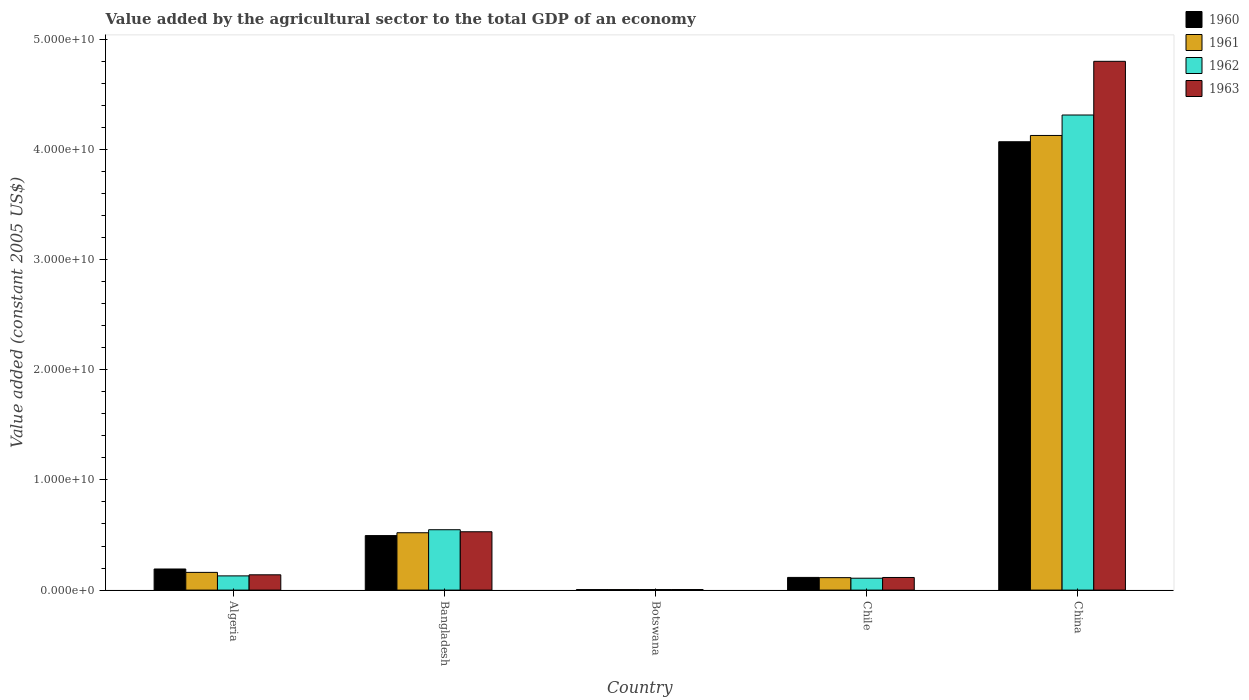How many groups of bars are there?
Your response must be concise. 5. Are the number of bars per tick equal to the number of legend labels?
Offer a very short reply. Yes. How many bars are there on the 5th tick from the left?
Ensure brevity in your answer.  4. How many bars are there on the 4th tick from the right?
Provide a succinct answer. 4. What is the label of the 2nd group of bars from the left?
Offer a terse response. Bangladesh. What is the value added by the agricultural sector in 1961 in Bangladesh?
Offer a terse response. 5.21e+09. Across all countries, what is the maximum value added by the agricultural sector in 1963?
Make the answer very short. 4.80e+1. Across all countries, what is the minimum value added by the agricultural sector in 1961?
Make the answer very short. 4.86e+07. In which country was the value added by the agricultural sector in 1961 minimum?
Your answer should be compact. Botswana. What is the total value added by the agricultural sector in 1961 in the graph?
Offer a terse response. 4.93e+1. What is the difference between the value added by the agricultural sector in 1961 in Bangladesh and that in Chile?
Give a very brief answer. 4.08e+09. What is the difference between the value added by the agricultural sector in 1961 in Algeria and the value added by the agricultural sector in 1962 in Chile?
Provide a succinct answer. 5.29e+08. What is the average value added by the agricultural sector in 1962 per country?
Offer a terse response. 1.02e+1. What is the difference between the value added by the agricultural sector of/in 1960 and value added by the agricultural sector of/in 1961 in Algeria?
Give a very brief answer. 3.07e+08. In how many countries, is the value added by the agricultural sector in 1960 greater than 20000000000 US$?
Ensure brevity in your answer.  1. What is the ratio of the value added by the agricultural sector in 1960 in Algeria to that in Botswana?
Provide a short and direct response. 40.37. What is the difference between the highest and the second highest value added by the agricultural sector in 1961?
Give a very brief answer. -3.61e+1. What is the difference between the highest and the lowest value added by the agricultural sector in 1962?
Your response must be concise. 4.31e+1. Is the sum of the value added by the agricultural sector in 1963 in Bangladesh and Botswana greater than the maximum value added by the agricultural sector in 1961 across all countries?
Ensure brevity in your answer.  No. Is it the case that in every country, the sum of the value added by the agricultural sector in 1963 and value added by the agricultural sector in 1960 is greater than the sum of value added by the agricultural sector in 1961 and value added by the agricultural sector in 1962?
Your answer should be very brief. No. What does the 2nd bar from the left in China represents?
Provide a succinct answer. 1961. What does the 2nd bar from the right in Bangladesh represents?
Provide a succinct answer. 1962. Is it the case that in every country, the sum of the value added by the agricultural sector in 1961 and value added by the agricultural sector in 1962 is greater than the value added by the agricultural sector in 1960?
Provide a short and direct response. Yes. Are all the bars in the graph horizontal?
Keep it short and to the point. No. How many countries are there in the graph?
Make the answer very short. 5. Does the graph contain any zero values?
Provide a short and direct response. No. How many legend labels are there?
Provide a succinct answer. 4. How are the legend labels stacked?
Provide a succinct answer. Vertical. What is the title of the graph?
Make the answer very short. Value added by the agricultural sector to the total GDP of an economy. What is the label or title of the Y-axis?
Keep it short and to the point. Value added (constant 2005 US$). What is the Value added (constant 2005 US$) of 1960 in Algeria?
Give a very brief answer. 1.92e+09. What is the Value added (constant 2005 US$) of 1961 in Algeria?
Make the answer very short. 1.61e+09. What is the Value added (constant 2005 US$) of 1962 in Algeria?
Give a very brief answer. 1.29e+09. What is the Value added (constant 2005 US$) in 1963 in Algeria?
Provide a succinct answer. 1.39e+09. What is the Value added (constant 2005 US$) in 1960 in Bangladesh?
Offer a terse response. 4.95e+09. What is the Value added (constant 2005 US$) in 1961 in Bangladesh?
Offer a terse response. 5.21e+09. What is the Value added (constant 2005 US$) of 1962 in Bangladesh?
Give a very brief answer. 5.48e+09. What is the Value added (constant 2005 US$) of 1963 in Bangladesh?
Make the answer very short. 5.30e+09. What is the Value added (constant 2005 US$) of 1960 in Botswana?
Give a very brief answer. 4.74e+07. What is the Value added (constant 2005 US$) of 1961 in Botswana?
Give a very brief answer. 4.86e+07. What is the Value added (constant 2005 US$) in 1962 in Botswana?
Your answer should be compact. 5.04e+07. What is the Value added (constant 2005 US$) of 1963 in Botswana?
Offer a very short reply. 5.21e+07. What is the Value added (constant 2005 US$) in 1960 in Chile?
Give a very brief answer. 1.15e+09. What is the Value added (constant 2005 US$) of 1961 in Chile?
Ensure brevity in your answer.  1.13e+09. What is the Value added (constant 2005 US$) of 1962 in Chile?
Offer a terse response. 1.08e+09. What is the Value added (constant 2005 US$) in 1963 in Chile?
Your response must be concise. 1.15e+09. What is the Value added (constant 2005 US$) of 1960 in China?
Make the answer very short. 4.07e+1. What is the Value added (constant 2005 US$) of 1961 in China?
Your answer should be compact. 4.13e+1. What is the Value added (constant 2005 US$) in 1962 in China?
Keep it short and to the point. 4.31e+1. What is the Value added (constant 2005 US$) of 1963 in China?
Keep it short and to the point. 4.80e+1. Across all countries, what is the maximum Value added (constant 2005 US$) of 1960?
Make the answer very short. 4.07e+1. Across all countries, what is the maximum Value added (constant 2005 US$) in 1961?
Keep it short and to the point. 4.13e+1. Across all countries, what is the maximum Value added (constant 2005 US$) of 1962?
Provide a short and direct response. 4.31e+1. Across all countries, what is the maximum Value added (constant 2005 US$) of 1963?
Your answer should be very brief. 4.80e+1. Across all countries, what is the minimum Value added (constant 2005 US$) in 1960?
Keep it short and to the point. 4.74e+07. Across all countries, what is the minimum Value added (constant 2005 US$) in 1961?
Keep it short and to the point. 4.86e+07. Across all countries, what is the minimum Value added (constant 2005 US$) in 1962?
Make the answer very short. 5.04e+07. Across all countries, what is the minimum Value added (constant 2005 US$) in 1963?
Keep it short and to the point. 5.21e+07. What is the total Value added (constant 2005 US$) of 1960 in the graph?
Offer a very short reply. 4.88e+1. What is the total Value added (constant 2005 US$) of 1961 in the graph?
Provide a short and direct response. 4.93e+1. What is the total Value added (constant 2005 US$) of 1962 in the graph?
Make the answer very short. 5.10e+1. What is the total Value added (constant 2005 US$) of 1963 in the graph?
Keep it short and to the point. 5.59e+1. What is the difference between the Value added (constant 2005 US$) of 1960 in Algeria and that in Bangladesh?
Offer a terse response. -3.03e+09. What is the difference between the Value added (constant 2005 US$) in 1961 in Algeria and that in Bangladesh?
Your answer should be compact. -3.60e+09. What is the difference between the Value added (constant 2005 US$) in 1962 in Algeria and that in Bangladesh?
Keep it short and to the point. -4.19e+09. What is the difference between the Value added (constant 2005 US$) of 1963 in Algeria and that in Bangladesh?
Your response must be concise. -3.91e+09. What is the difference between the Value added (constant 2005 US$) of 1960 in Algeria and that in Botswana?
Provide a short and direct response. 1.87e+09. What is the difference between the Value added (constant 2005 US$) in 1961 in Algeria and that in Botswana?
Ensure brevity in your answer.  1.56e+09. What is the difference between the Value added (constant 2005 US$) of 1962 in Algeria and that in Botswana?
Your answer should be very brief. 1.24e+09. What is the difference between the Value added (constant 2005 US$) in 1963 in Algeria and that in Botswana?
Offer a very short reply. 1.34e+09. What is the difference between the Value added (constant 2005 US$) of 1960 in Algeria and that in Chile?
Keep it short and to the point. 7.63e+08. What is the difference between the Value added (constant 2005 US$) of 1961 in Algeria and that in Chile?
Provide a short and direct response. 4.78e+08. What is the difference between the Value added (constant 2005 US$) in 1962 in Algeria and that in Chile?
Ensure brevity in your answer.  2.11e+08. What is the difference between the Value added (constant 2005 US$) of 1963 in Algeria and that in Chile?
Provide a short and direct response. 2.42e+08. What is the difference between the Value added (constant 2005 US$) in 1960 in Algeria and that in China?
Provide a short and direct response. -3.88e+1. What is the difference between the Value added (constant 2005 US$) of 1961 in Algeria and that in China?
Your response must be concise. -3.97e+1. What is the difference between the Value added (constant 2005 US$) of 1962 in Algeria and that in China?
Your answer should be very brief. -4.18e+1. What is the difference between the Value added (constant 2005 US$) of 1963 in Algeria and that in China?
Your response must be concise. -4.66e+1. What is the difference between the Value added (constant 2005 US$) in 1960 in Bangladesh and that in Botswana?
Provide a succinct answer. 4.90e+09. What is the difference between the Value added (constant 2005 US$) of 1961 in Bangladesh and that in Botswana?
Ensure brevity in your answer.  5.16e+09. What is the difference between the Value added (constant 2005 US$) in 1962 in Bangladesh and that in Botswana?
Provide a succinct answer. 5.43e+09. What is the difference between the Value added (constant 2005 US$) of 1963 in Bangladesh and that in Botswana?
Ensure brevity in your answer.  5.24e+09. What is the difference between the Value added (constant 2005 US$) in 1960 in Bangladesh and that in Chile?
Provide a short and direct response. 3.80e+09. What is the difference between the Value added (constant 2005 US$) of 1961 in Bangladesh and that in Chile?
Give a very brief answer. 4.08e+09. What is the difference between the Value added (constant 2005 US$) in 1962 in Bangladesh and that in Chile?
Offer a very short reply. 4.40e+09. What is the difference between the Value added (constant 2005 US$) of 1963 in Bangladesh and that in Chile?
Your answer should be compact. 4.15e+09. What is the difference between the Value added (constant 2005 US$) of 1960 in Bangladesh and that in China?
Provide a succinct answer. -3.57e+1. What is the difference between the Value added (constant 2005 US$) in 1961 in Bangladesh and that in China?
Ensure brevity in your answer.  -3.61e+1. What is the difference between the Value added (constant 2005 US$) in 1962 in Bangladesh and that in China?
Make the answer very short. -3.76e+1. What is the difference between the Value added (constant 2005 US$) in 1963 in Bangladesh and that in China?
Provide a succinct answer. -4.27e+1. What is the difference between the Value added (constant 2005 US$) of 1960 in Botswana and that in Chile?
Offer a terse response. -1.10e+09. What is the difference between the Value added (constant 2005 US$) in 1961 in Botswana and that in Chile?
Make the answer very short. -1.08e+09. What is the difference between the Value added (constant 2005 US$) of 1962 in Botswana and that in Chile?
Your answer should be compact. -1.03e+09. What is the difference between the Value added (constant 2005 US$) of 1963 in Botswana and that in Chile?
Your response must be concise. -1.09e+09. What is the difference between the Value added (constant 2005 US$) of 1960 in Botswana and that in China?
Your answer should be compact. -4.07e+1. What is the difference between the Value added (constant 2005 US$) of 1961 in Botswana and that in China?
Your answer should be very brief. -4.12e+1. What is the difference between the Value added (constant 2005 US$) of 1962 in Botswana and that in China?
Provide a short and direct response. -4.31e+1. What is the difference between the Value added (constant 2005 US$) of 1963 in Botswana and that in China?
Keep it short and to the point. -4.79e+1. What is the difference between the Value added (constant 2005 US$) in 1960 in Chile and that in China?
Offer a terse response. -3.95e+1. What is the difference between the Value added (constant 2005 US$) of 1961 in Chile and that in China?
Your answer should be very brief. -4.01e+1. What is the difference between the Value added (constant 2005 US$) in 1962 in Chile and that in China?
Offer a very short reply. -4.20e+1. What is the difference between the Value added (constant 2005 US$) in 1963 in Chile and that in China?
Ensure brevity in your answer.  -4.69e+1. What is the difference between the Value added (constant 2005 US$) of 1960 in Algeria and the Value added (constant 2005 US$) of 1961 in Bangladesh?
Your answer should be compact. -3.29e+09. What is the difference between the Value added (constant 2005 US$) in 1960 in Algeria and the Value added (constant 2005 US$) in 1962 in Bangladesh?
Ensure brevity in your answer.  -3.56e+09. What is the difference between the Value added (constant 2005 US$) of 1960 in Algeria and the Value added (constant 2005 US$) of 1963 in Bangladesh?
Your answer should be very brief. -3.38e+09. What is the difference between the Value added (constant 2005 US$) of 1961 in Algeria and the Value added (constant 2005 US$) of 1962 in Bangladesh?
Provide a short and direct response. -3.87e+09. What is the difference between the Value added (constant 2005 US$) in 1961 in Algeria and the Value added (constant 2005 US$) in 1963 in Bangladesh?
Your answer should be very brief. -3.69e+09. What is the difference between the Value added (constant 2005 US$) of 1962 in Algeria and the Value added (constant 2005 US$) of 1963 in Bangladesh?
Provide a short and direct response. -4.00e+09. What is the difference between the Value added (constant 2005 US$) in 1960 in Algeria and the Value added (constant 2005 US$) in 1961 in Botswana?
Your answer should be compact. 1.87e+09. What is the difference between the Value added (constant 2005 US$) of 1960 in Algeria and the Value added (constant 2005 US$) of 1962 in Botswana?
Your answer should be compact. 1.86e+09. What is the difference between the Value added (constant 2005 US$) in 1960 in Algeria and the Value added (constant 2005 US$) in 1963 in Botswana?
Your response must be concise. 1.86e+09. What is the difference between the Value added (constant 2005 US$) of 1961 in Algeria and the Value added (constant 2005 US$) of 1962 in Botswana?
Provide a succinct answer. 1.56e+09. What is the difference between the Value added (constant 2005 US$) of 1961 in Algeria and the Value added (constant 2005 US$) of 1963 in Botswana?
Provide a short and direct response. 1.56e+09. What is the difference between the Value added (constant 2005 US$) in 1962 in Algeria and the Value added (constant 2005 US$) in 1963 in Botswana?
Provide a succinct answer. 1.24e+09. What is the difference between the Value added (constant 2005 US$) of 1960 in Algeria and the Value added (constant 2005 US$) of 1961 in Chile?
Keep it short and to the point. 7.85e+08. What is the difference between the Value added (constant 2005 US$) in 1960 in Algeria and the Value added (constant 2005 US$) in 1962 in Chile?
Keep it short and to the point. 8.36e+08. What is the difference between the Value added (constant 2005 US$) in 1960 in Algeria and the Value added (constant 2005 US$) in 1963 in Chile?
Ensure brevity in your answer.  7.69e+08. What is the difference between the Value added (constant 2005 US$) in 1961 in Algeria and the Value added (constant 2005 US$) in 1962 in Chile?
Provide a short and direct response. 5.29e+08. What is the difference between the Value added (constant 2005 US$) in 1961 in Algeria and the Value added (constant 2005 US$) in 1963 in Chile?
Provide a short and direct response. 4.62e+08. What is the difference between the Value added (constant 2005 US$) in 1962 in Algeria and the Value added (constant 2005 US$) in 1963 in Chile?
Ensure brevity in your answer.  1.44e+08. What is the difference between the Value added (constant 2005 US$) in 1960 in Algeria and the Value added (constant 2005 US$) in 1961 in China?
Ensure brevity in your answer.  -3.94e+1. What is the difference between the Value added (constant 2005 US$) of 1960 in Algeria and the Value added (constant 2005 US$) of 1962 in China?
Provide a succinct answer. -4.12e+1. What is the difference between the Value added (constant 2005 US$) in 1960 in Algeria and the Value added (constant 2005 US$) in 1963 in China?
Provide a succinct answer. -4.61e+1. What is the difference between the Value added (constant 2005 US$) in 1961 in Algeria and the Value added (constant 2005 US$) in 1962 in China?
Give a very brief answer. -4.15e+1. What is the difference between the Value added (constant 2005 US$) of 1961 in Algeria and the Value added (constant 2005 US$) of 1963 in China?
Provide a short and direct response. -4.64e+1. What is the difference between the Value added (constant 2005 US$) of 1962 in Algeria and the Value added (constant 2005 US$) of 1963 in China?
Your response must be concise. -4.67e+1. What is the difference between the Value added (constant 2005 US$) in 1960 in Bangladesh and the Value added (constant 2005 US$) in 1961 in Botswana?
Provide a succinct answer. 4.90e+09. What is the difference between the Value added (constant 2005 US$) of 1960 in Bangladesh and the Value added (constant 2005 US$) of 1962 in Botswana?
Your answer should be compact. 4.90e+09. What is the difference between the Value added (constant 2005 US$) of 1960 in Bangladesh and the Value added (constant 2005 US$) of 1963 in Botswana?
Ensure brevity in your answer.  4.90e+09. What is the difference between the Value added (constant 2005 US$) in 1961 in Bangladesh and the Value added (constant 2005 US$) in 1962 in Botswana?
Ensure brevity in your answer.  5.16e+09. What is the difference between the Value added (constant 2005 US$) of 1961 in Bangladesh and the Value added (constant 2005 US$) of 1963 in Botswana?
Keep it short and to the point. 5.15e+09. What is the difference between the Value added (constant 2005 US$) of 1962 in Bangladesh and the Value added (constant 2005 US$) of 1963 in Botswana?
Ensure brevity in your answer.  5.43e+09. What is the difference between the Value added (constant 2005 US$) of 1960 in Bangladesh and the Value added (constant 2005 US$) of 1961 in Chile?
Provide a short and direct response. 3.82e+09. What is the difference between the Value added (constant 2005 US$) of 1960 in Bangladesh and the Value added (constant 2005 US$) of 1962 in Chile?
Provide a short and direct response. 3.87e+09. What is the difference between the Value added (constant 2005 US$) of 1960 in Bangladesh and the Value added (constant 2005 US$) of 1963 in Chile?
Provide a short and direct response. 3.80e+09. What is the difference between the Value added (constant 2005 US$) of 1961 in Bangladesh and the Value added (constant 2005 US$) of 1962 in Chile?
Make the answer very short. 4.13e+09. What is the difference between the Value added (constant 2005 US$) of 1961 in Bangladesh and the Value added (constant 2005 US$) of 1963 in Chile?
Give a very brief answer. 4.06e+09. What is the difference between the Value added (constant 2005 US$) of 1962 in Bangladesh and the Value added (constant 2005 US$) of 1963 in Chile?
Your response must be concise. 4.33e+09. What is the difference between the Value added (constant 2005 US$) in 1960 in Bangladesh and the Value added (constant 2005 US$) in 1961 in China?
Provide a succinct answer. -3.63e+1. What is the difference between the Value added (constant 2005 US$) of 1960 in Bangladesh and the Value added (constant 2005 US$) of 1962 in China?
Provide a succinct answer. -3.82e+1. What is the difference between the Value added (constant 2005 US$) in 1960 in Bangladesh and the Value added (constant 2005 US$) in 1963 in China?
Give a very brief answer. -4.30e+1. What is the difference between the Value added (constant 2005 US$) in 1961 in Bangladesh and the Value added (constant 2005 US$) in 1962 in China?
Offer a terse response. -3.79e+1. What is the difference between the Value added (constant 2005 US$) in 1961 in Bangladesh and the Value added (constant 2005 US$) in 1963 in China?
Your response must be concise. -4.28e+1. What is the difference between the Value added (constant 2005 US$) of 1962 in Bangladesh and the Value added (constant 2005 US$) of 1963 in China?
Give a very brief answer. -4.25e+1. What is the difference between the Value added (constant 2005 US$) in 1960 in Botswana and the Value added (constant 2005 US$) in 1961 in Chile?
Provide a succinct answer. -1.08e+09. What is the difference between the Value added (constant 2005 US$) in 1960 in Botswana and the Value added (constant 2005 US$) in 1962 in Chile?
Your answer should be compact. -1.03e+09. What is the difference between the Value added (constant 2005 US$) of 1960 in Botswana and the Value added (constant 2005 US$) of 1963 in Chile?
Ensure brevity in your answer.  -1.10e+09. What is the difference between the Value added (constant 2005 US$) of 1961 in Botswana and the Value added (constant 2005 US$) of 1962 in Chile?
Make the answer very short. -1.03e+09. What is the difference between the Value added (constant 2005 US$) in 1961 in Botswana and the Value added (constant 2005 US$) in 1963 in Chile?
Provide a succinct answer. -1.10e+09. What is the difference between the Value added (constant 2005 US$) of 1962 in Botswana and the Value added (constant 2005 US$) of 1963 in Chile?
Your answer should be very brief. -1.10e+09. What is the difference between the Value added (constant 2005 US$) of 1960 in Botswana and the Value added (constant 2005 US$) of 1961 in China?
Keep it short and to the point. -4.12e+1. What is the difference between the Value added (constant 2005 US$) of 1960 in Botswana and the Value added (constant 2005 US$) of 1962 in China?
Your answer should be compact. -4.31e+1. What is the difference between the Value added (constant 2005 US$) of 1960 in Botswana and the Value added (constant 2005 US$) of 1963 in China?
Ensure brevity in your answer.  -4.80e+1. What is the difference between the Value added (constant 2005 US$) of 1961 in Botswana and the Value added (constant 2005 US$) of 1962 in China?
Keep it short and to the point. -4.31e+1. What is the difference between the Value added (constant 2005 US$) of 1961 in Botswana and the Value added (constant 2005 US$) of 1963 in China?
Make the answer very short. -4.79e+1. What is the difference between the Value added (constant 2005 US$) of 1962 in Botswana and the Value added (constant 2005 US$) of 1963 in China?
Your answer should be very brief. -4.79e+1. What is the difference between the Value added (constant 2005 US$) in 1960 in Chile and the Value added (constant 2005 US$) in 1961 in China?
Provide a succinct answer. -4.01e+1. What is the difference between the Value added (constant 2005 US$) of 1960 in Chile and the Value added (constant 2005 US$) of 1962 in China?
Offer a very short reply. -4.20e+1. What is the difference between the Value added (constant 2005 US$) of 1960 in Chile and the Value added (constant 2005 US$) of 1963 in China?
Your response must be concise. -4.68e+1. What is the difference between the Value added (constant 2005 US$) of 1961 in Chile and the Value added (constant 2005 US$) of 1962 in China?
Make the answer very short. -4.20e+1. What is the difference between the Value added (constant 2005 US$) of 1961 in Chile and the Value added (constant 2005 US$) of 1963 in China?
Offer a terse response. -4.69e+1. What is the difference between the Value added (constant 2005 US$) in 1962 in Chile and the Value added (constant 2005 US$) in 1963 in China?
Keep it short and to the point. -4.69e+1. What is the average Value added (constant 2005 US$) of 1960 per country?
Offer a terse response. 9.75e+09. What is the average Value added (constant 2005 US$) of 1961 per country?
Give a very brief answer. 9.85e+09. What is the average Value added (constant 2005 US$) of 1962 per country?
Your answer should be compact. 1.02e+1. What is the average Value added (constant 2005 US$) in 1963 per country?
Provide a short and direct response. 1.12e+1. What is the difference between the Value added (constant 2005 US$) of 1960 and Value added (constant 2005 US$) of 1961 in Algeria?
Ensure brevity in your answer.  3.07e+08. What is the difference between the Value added (constant 2005 US$) of 1960 and Value added (constant 2005 US$) of 1962 in Algeria?
Offer a very short reply. 6.25e+08. What is the difference between the Value added (constant 2005 US$) in 1960 and Value added (constant 2005 US$) in 1963 in Algeria?
Give a very brief answer. 5.27e+08. What is the difference between the Value added (constant 2005 US$) of 1961 and Value added (constant 2005 US$) of 1962 in Algeria?
Offer a terse response. 3.18e+08. What is the difference between the Value added (constant 2005 US$) of 1961 and Value added (constant 2005 US$) of 1963 in Algeria?
Give a very brief answer. 2.20e+08. What is the difference between the Value added (constant 2005 US$) in 1962 and Value added (constant 2005 US$) in 1963 in Algeria?
Your answer should be compact. -9.79e+07. What is the difference between the Value added (constant 2005 US$) in 1960 and Value added (constant 2005 US$) in 1961 in Bangladesh?
Ensure brevity in your answer.  -2.58e+08. What is the difference between the Value added (constant 2005 US$) in 1960 and Value added (constant 2005 US$) in 1962 in Bangladesh?
Keep it short and to the point. -5.31e+08. What is the difference between the Value added (constant 2005 US$) of 1960 and Value added (constant 2005 US$) of 1963 in Bangladesh?
Provide a succinct answer. -3.47e+08. What is the difference between the Value added (constant 2005 US$) in 1961 and Value added (constant 2005 US$) in 1962 in Bangladesh?
Offer a terse response. -2.73e+08. What is the difference between the Value added (constant 2005 US$) in 1961 and Value added (constant 2005 US$) in 1963 in Bangladesh?
Offer a terse response. -8.88e+07. What is the difference between the Value added (constant 2005 US$) of 1962 and Value added (constant 2005 US$) of 1963 in Bangladesh?
Keep it short and to the point. 1.84e+08. What is the difference between the Value added (constant 2005 US$) in 1960 and Value added (constant 2005 US$) in 1961 in Botswana?
Make the answer very short. -1.17e+06. What is the difference between the Value added (constant 2005 US$) of 1960 and Value added (constant 2005 US$) of 1962 in Botswana?
Ensure brevity in your answer.  -2.92e+06. What is the difference between the Value added (constant 2005 US$) in 1960 and Value added (constant 2005 US$) in 1963 in Botswana?
Keep it short and to the point. -4.67e+06. What is the difference between the Value added (constant 2005 US$) in 1961 and Value added (constant 2005 US$) in 1962 in Botswana?
Make the answer very short. -1.75e+06. What is the difference between the Value added (constant 2005 US$) of 1961 and Value added (constant 2005 US$) of 1963 in Botswana?
Offer a terse response. -3.51e+06. What is the difference between the Value added (constant 2005 US$) of 1962 and Value added (constant 2005 US$) of 1963 in Botswana?
Offer a very short reply. -1.75e+06. What is the difference between the Value added (constant 2005 US$) in 1960 and Value added (constant 2005 US$) in 1961 in Chile?
Offer a very short reply. 2.12e+07. What is the difference between the Value added (constant 2005 US$) in 1960 and Value added (constant 2005 US$) in 1962 in Chile?
Ensure brevity in your answer.  7.27e+07. What is the difference between the Value added (constant 2005 US$) of 1960 and Value added (constant 2005 US$) of 1963 in Chile?
Your answer should be very brief. 5.74e+06. What is the difference between the Value added (constant 2005 US$) in 1961 and Value added (constant 2005 US$) in 1962 in Chile?
Offer a terse response. 5.15e+07. What is the difference between the Value added (constant 2005 US$) in 1961 and Value added (constant 2005 US$) in 1963 in Chile?
Offer a terse response. -1.54e+07. What is the difference between the Value added (constant 2005 US$) in 1962 and Value added (constant 2005 US$) in 1963 in Chile?
Provide a succinct answer. -6.69e+07. What is the difference between the Value added (constant 2005 US$) in 1960 and Value added (constant 2005 US$) in 1961 in China?
Your answer should be very brief. -5.70e+08. What is the difference between the Value added (constant 2005 US$) of 1960 and Value added (constant 2005 US$) of 1962 in China?
Provide a short and direct response. -2.43e+09. What is the difference between the Value added (constant 2005 US$) in 1960 and Value added (constant 2005 US$) in 1963 in China?
Provide a short and direct response. -7.30e+09. What is the difference between the Value added (constant 2005 US$) of 1961 and Value added (constant 2005 US$) of 1962 in China?
Your response must be concise. -1.86e+09. What is the difference between the Value added (constant 2005 US$) of 1961 and Value added (constant 2005 US$) of 1963 in China?
Give a very brief answer. -6.73e+09. What is the difference between the Value added (constant 2005 US$) in 1962 and Value added (constant 2005 US$) in 1963 in China?
Your answer should be very brief. -4.87e+09. What is the ratio of the Value added (constant 2005 US$) in 1960 in Algeria to that in Bangladesh?
Keep it short and to the point. 0.39. What is the ratio of the Value added (constant 2005 US$) of 1961 in Algeria to that in Bangladesh?
Offer a very short reply. 0.31. What is the ratio of the Value added (constant 2005 US$) in 1962 in Algeria to that in Bangladesh?
Offer a very short reply. 0.24. What is the ratio of the Value added (constant 2005 US$) in 1963 in Algeria to that in Bangladesh?
Keep it short and to the point. 0.26. What is the ratio of the Value added (constant 2005 US$) of 1960 in Algeria to that in Botswana?
Make the answer very short. 40.37. What is the ratio of the Value added (constant 2005 US$) of 1961 in Algeria to that in Botswana?
Ensure brevity in your answer.  33.08. What is the ratio of the Value added (constant 2005 US$) of 1962 in Algeria to that in Botswana?
Provide a short and direct response. 25.62. What is the ratio of the Value added (constant 2005 US$) of 1963 in Algeria to that in Botswana?
Provide a short and direct response. 26.63. What is the ratio of the Value added (constant 2005 US$) of 1960 in Algeria to that in Chile?
Offer a terse response. 1.66. What is the ratio of the Value added (constant 2005 US$) of 1961 in Algeria to that in Chile?
Your response must be concise. 1.42. What is the ratio of the Value added (constant 2005 US$) in 1962 in Algeria to that in Chile?
Your answer should be very brief. 1.2. What is the ratio of the Value added (constant 2005 US$) in 1963 in Algeria to that in Chile?
Provide a short and direct response. 1.21. What is the ratio of the Value added (constant 2005 US$) in 1960 in Algeria to that in China?
Offer a very short reply. 0.05. What is the ratio of the Value added (constant 2005 US$) in 1961 in Algeria to that in China?
Make the answer very short. 0.04. What is the ratio of the Value added (constant 2005 US$) of 1962 in Algeria to that in China?
Give a very brief answer. 0.03. What is the ratio of the Value added (constant 2005 US$) of 1963 in Algeria to that in China?
Provide a short and direct response. 0.03. What is the ratio of the Value added (constant 2005 US$) of 1960 in Bangladesh to that in Botswana?
Offer a terse response. 104.3. What is the ratio of the Value added (constant 2005 US$) in 1961 in Bangladesh to that in Botswana?
Offer a very short reply. 107.09. What is the ratio of the Value added (constant 2005 US$) of 1962 in Bangladesh to that in Botswana?
Your answer should be very brief. 108.79. What is the ratio of the Value added (constant 2005 US$) of 1963 in Bangladesh to that in Botswana?
Your response must be concise. 101.59. What is the ratio of the Value added (constant 2005 US$) of 1960 in Bangladesh to that in Chile?
Keep it short and to the point. 4.3. What is the ratio of the Value added (constant 2005 US$) in 1961 in Bangladesh to that in Chile?
Ensure brevity in your answer.  4.6. What is the ratio of the Value added (constant 2005 US$) of 1962 in Bangladesh to that in Chile?
Provide a succinct answer. 5.08. What is the ratio of the Value added (constant 2005 US$) of 1963 in Bangladesh to that in Chile?
Keep it short and to the point. 4.62. What is the ratio of the Value added (constant 2005 US$) of 1960 in Bangladesh to that in China?
Keep it short and to the point. 0.12. What is the ratio of the Value added (constant 2005 US$) of 1961 in Bangladesh to that in China?
Keep it short and to the point. 0.13. What is the ratio of the Value added (constant 2005 US$) in 1962 in Bangladesh to that in China?
Offer a terse response. 0.13. What is the ratio of the Value added (constant 2005 US$) in 1963 in Bangladesh to that in China?
Make the answer very short. 0.11. What is the ratio of the Value added (constant 2005 US$) in 1960 in Botswana to that in Chile?
Give a very brief answer. 0.04. What is the ratio of the Value added (constant 2005 US$) in 1961 in Botswana to that in Chile?
Make the answer very short. 0.04. What is the ratio of the Value added (constant 2005 US$) of 1962 in Botswana to that in Chile?
Ensure brevity in your answer.  0.05. What is the ratio of the Value added (constant 2005 US$) of 1963 in Botswana to that in Chile?
Make the answer very short. 0.05. What is the ratio of the Value added (constant 2005 US$) in 1960 in Botswana to that in China?
Provide a short and direct response. 0. What is the ratio of the Value added (constant 2005 US$) in 1961 in Botswana to that in China?
Provide a short and direct response. 0. What is the ratio of the Value added (constant 2005 US$) of 1962 in Botswana to that in China?
Provide a succinct answer. 0. What is the ratio of the Value added (constant 2005 US$) of 1963 in Botswana to that in China?
Provide a succinct answer. 0. What is the ratio of the Value added (constant 2005 US$) of 1960 in Chile to that in China?
Ensure brevity in your answer.  0.03. What is the ratio of the Value added (constant 2005 US$) of 1961 in Chile to that in China?
Your response must be concise. 0.03. What is the ratio of the Value added (constant 2005 US$) in 1962 in Chile to that in China?
Keep it short and to the point. 0.03. What is the ratio of the Value added (constant 2005 US$) of 1963 in Chile to that in China?
Give a very brief answer. 0.02. What is the difference between the highest and the second highest Value added (constant 2005 US$) in 1960?
Provide a short and direct response. 3.57e+1. What is the difference between the highest and the second highest Value added (constant 2005 US$) in 1961?
Provide a succinct answer. 3.61e+1. What is the difference between the highest and the second highest Value added (constant 2005 US$) of 1962?
Your answer should be very brief. 3.76e+1. What is the difference between the highest and the second highest Value added (constant 2005 US$) of 1963?
Provide a short and direct response. 4.27e+1. What is the difference between the highest and the lowest Value added (constant 2005 US$) in 1960?
Your response must be concise. 4.07e+1. What is the difference between the highest and the lowest Value added (constant 2005 US$) in 1961?
Give a very brief answer. 4.12e+1. What is the difference between the highest and the lowest Value added (constant 2005 US$) of 1962?
Give a very brief answer. 4.31e+1. What is the difference between the highest and the lowest Value added (constant 2005 US$) in 1963?
Give a very brief answer. 4.79e+1. 